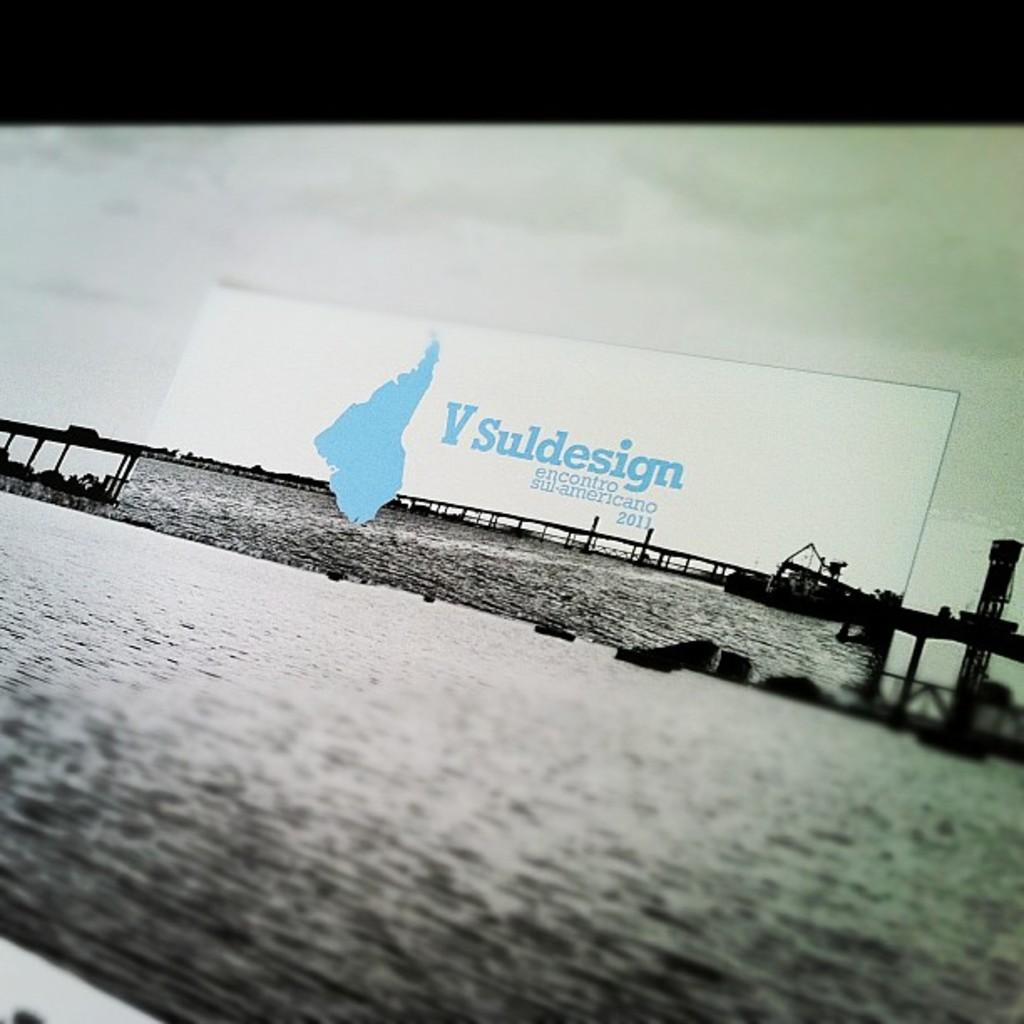<image>
Provide a brief description of the given image. The ad shown here is from the year 2011 